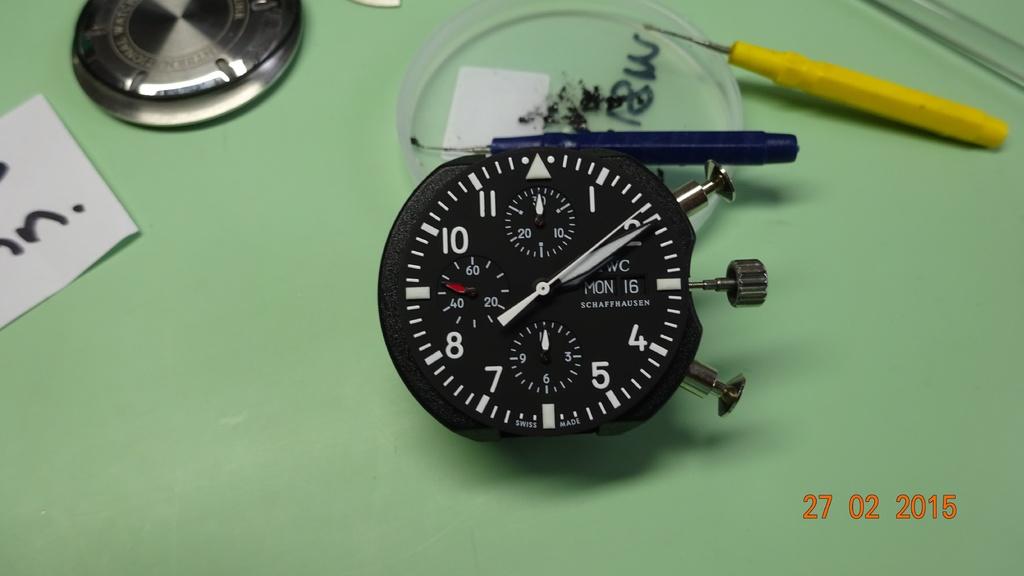When is this photo taken?
Your answer should be very brief. 27 02 2015. What day of the week is displayed on the watch face?
Your answer should be compact. Monday. 